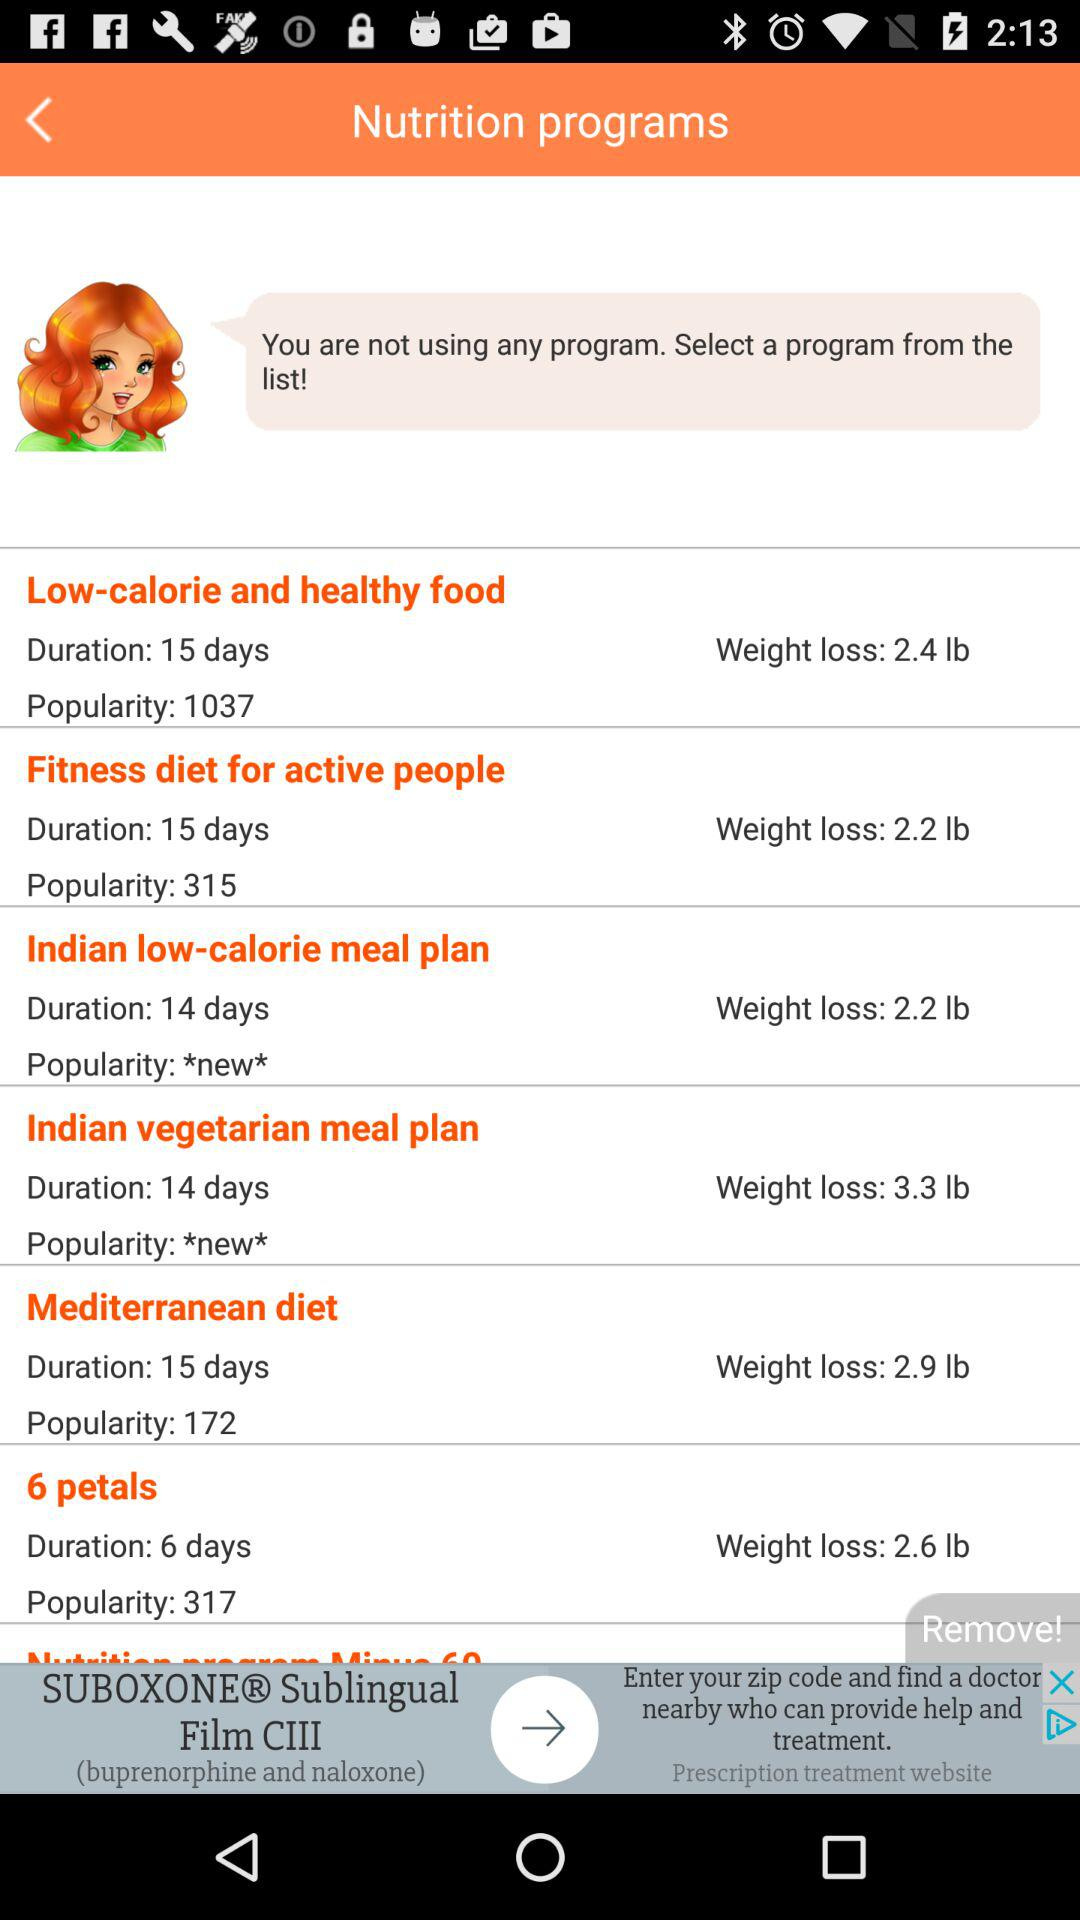How much weight can be lost using the "Indian vegetarian meal plan"? Using the "Indian vegetarian meal plan", 3.3 pounds of weight can be lost. 